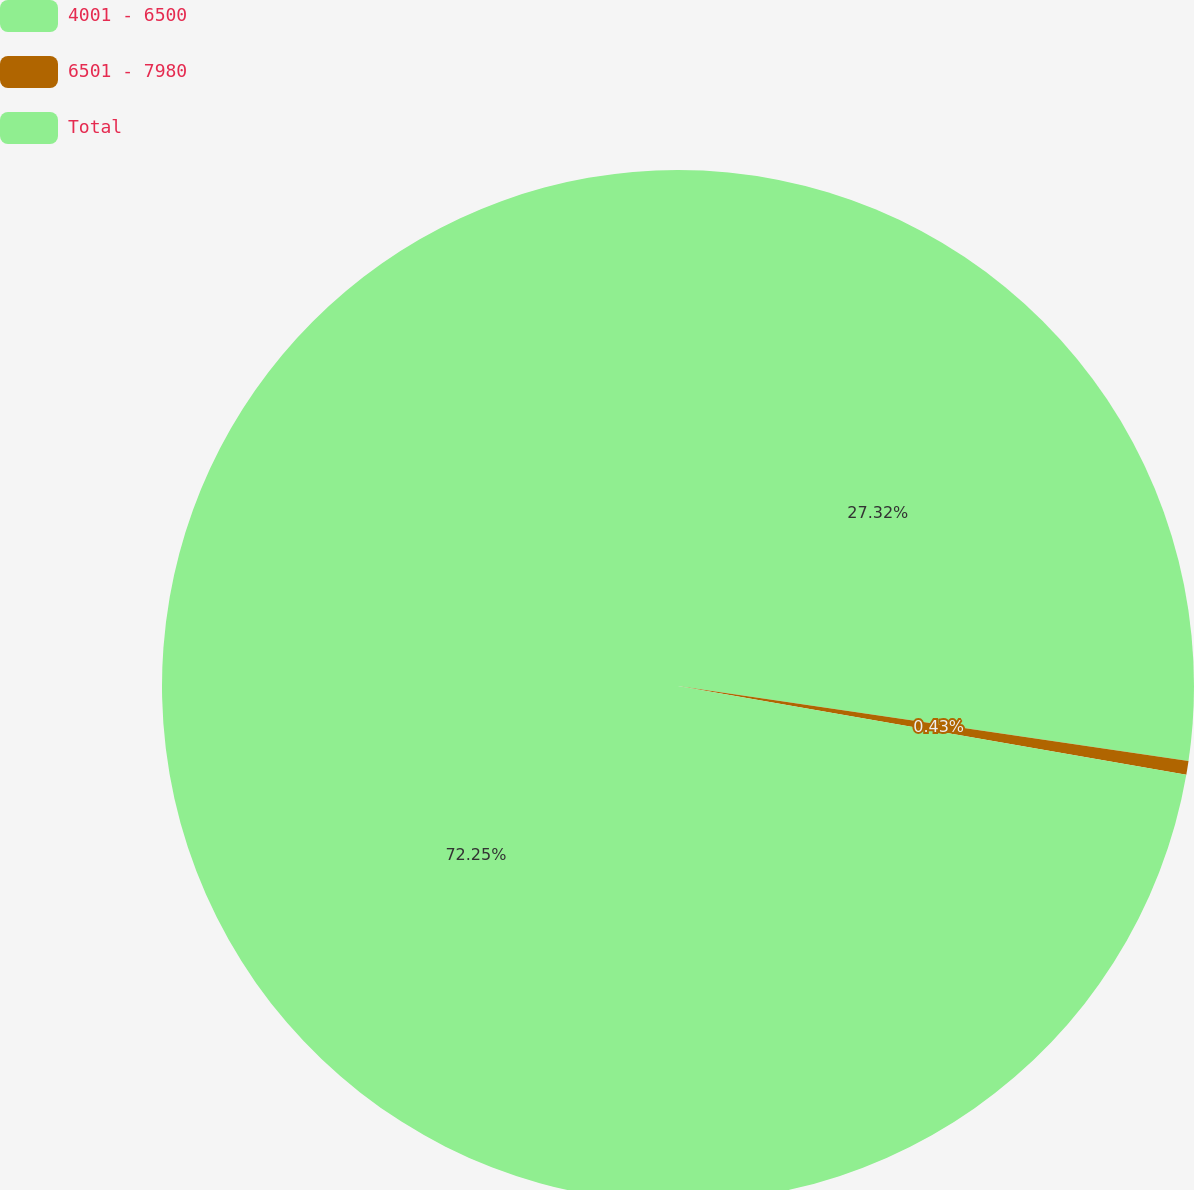Convert chart to OTSL. <chart><loc_0><loc_0><loc_500><loc_500><pie_chart><fcel>4001 - 6500<fcel>6501 - 7980<fcel>Total<nl><fcel>27.32%<fcel>0.43%<fcel>72.24%<nl></chart> 